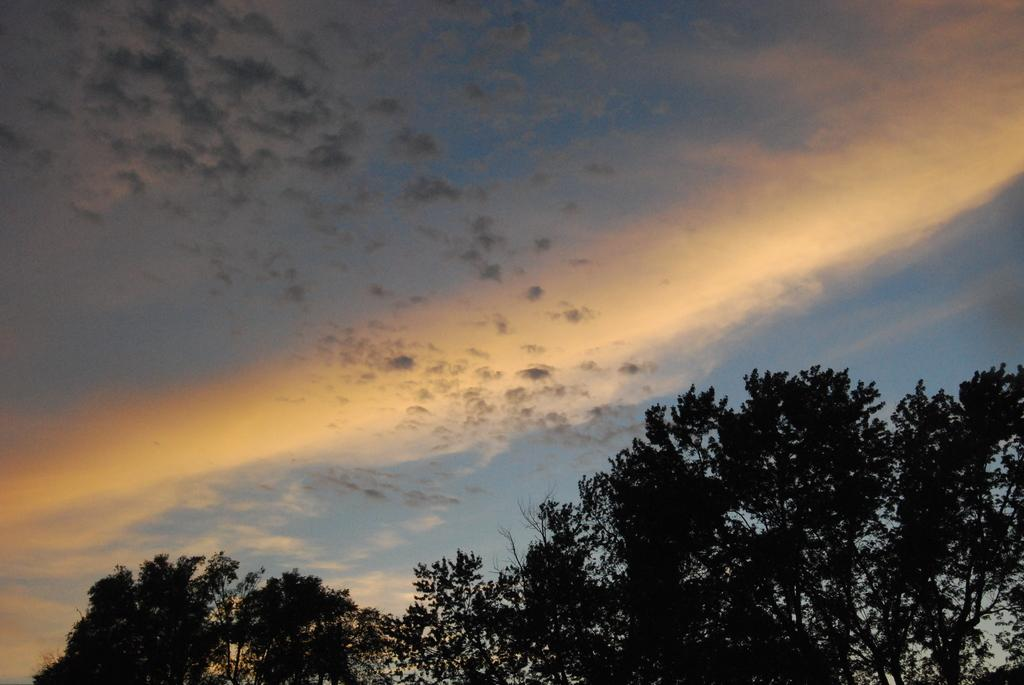What type of vegetation can be seen in the image? There are trees in the image. What is visible at the top of the image? The sky is visible at the top of the image. What can be seen in the sky at the top of the image? There are clouds in the sky at the top of the image. Where are the scissors located in the image? There are no scissors present in the image. What type of business is being conducted in the image? There is no business activity depicted in the image. 